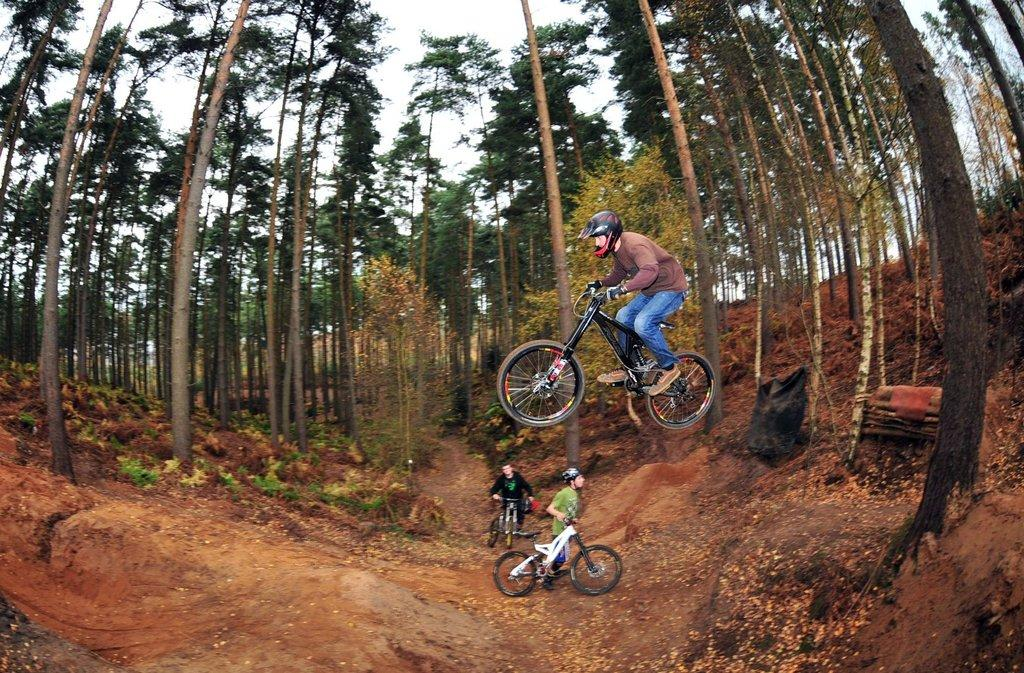Who or what can be seen in the image? There are people in the image. What are the people using in the image? There are bicycles in the image. What can be seen in the middle of the image? There are trees in the middle of the image. What type of snail can be seen teaching a journey in the image? There is no snail or journey present in the image; it features people and bicycles. 